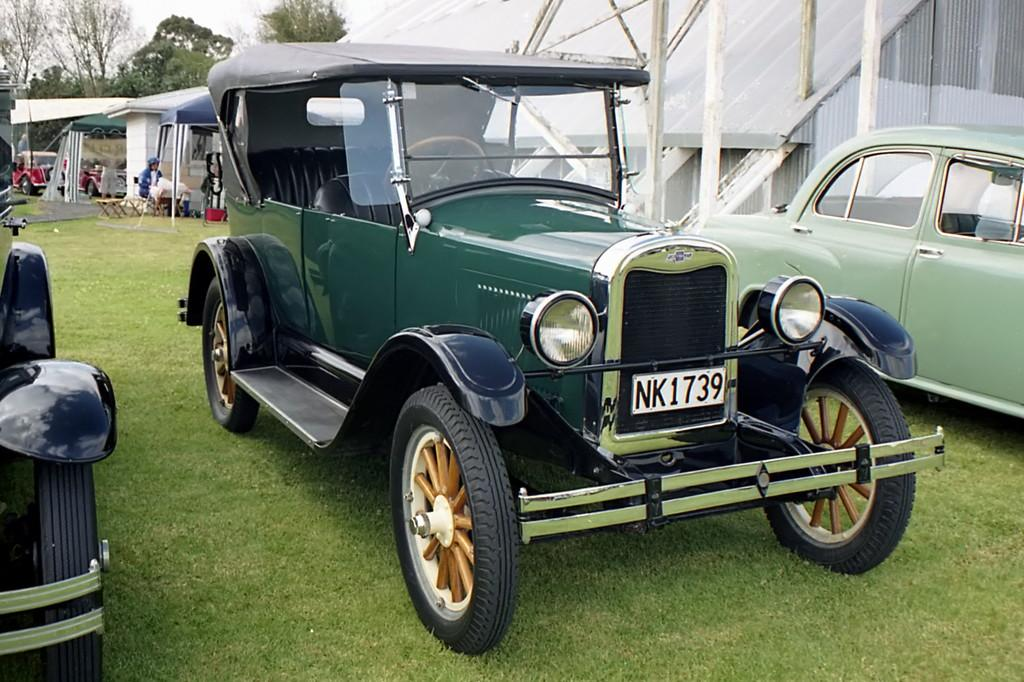What is located on the grass in the image? There are vehicles on the grass in the image. What type of structure can be seen in the image? There is a shed in the image. Can you describe the background of the image? In the background of the image, there is a person, chairs, tents, more vehicles, trees, and the sky. What type of secretary can be seen working in the image? There is no secretary present in the image. How much dust is visible on the vehicles in the image? There is no mention of dust in the image, so it cannot be determined how much dust is visible on the vehicles. 